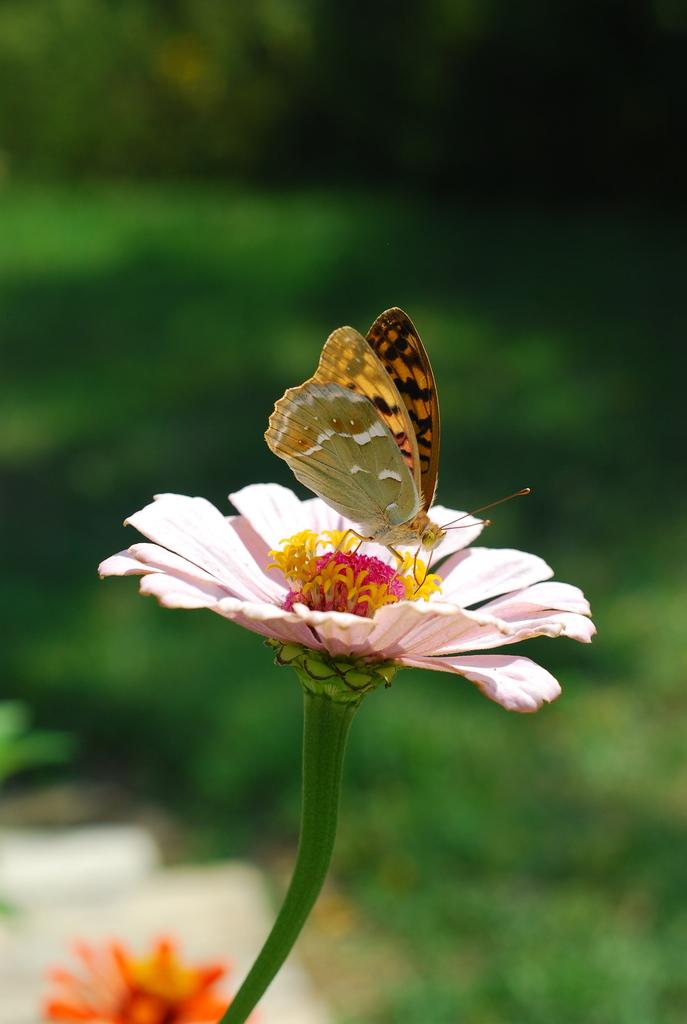What type of living organisms can be seen in the image? There are flowers and a butterfly in the image. Where is the butterfly located in relation to the flowers? The butterfly is on a flower in the image. What is the quality of the background in the image? The background of the image is blurry. What type of plastic material can be seen in the image? There is no plastic material present in the image. How does the butterfly increase its speed while flying in the image? The image does not show the butterfly flying, so it is not possible to determine how it might increase its speed. 